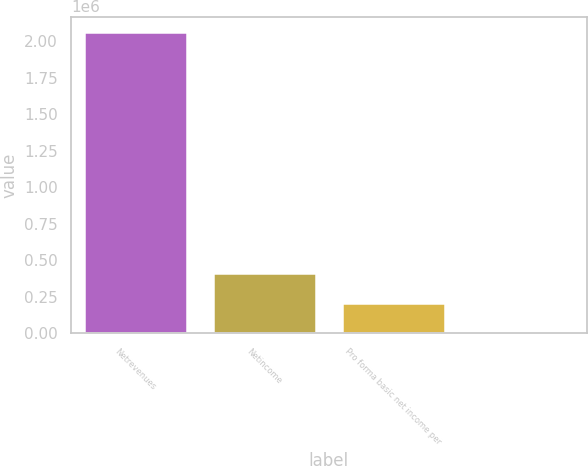Convert chart to OTSL. <chart><loc_0><loc_0><loc_500><loc_500><bar_chart><fcel>Netrevenues<fcel>Netincome<fcel>Pro forma basic net income per<fcel>Unnamed: 3<nl><fcel>2.06637e+06<fcel>413276<fcel>206639<fcel>2.56<nl></chart> 